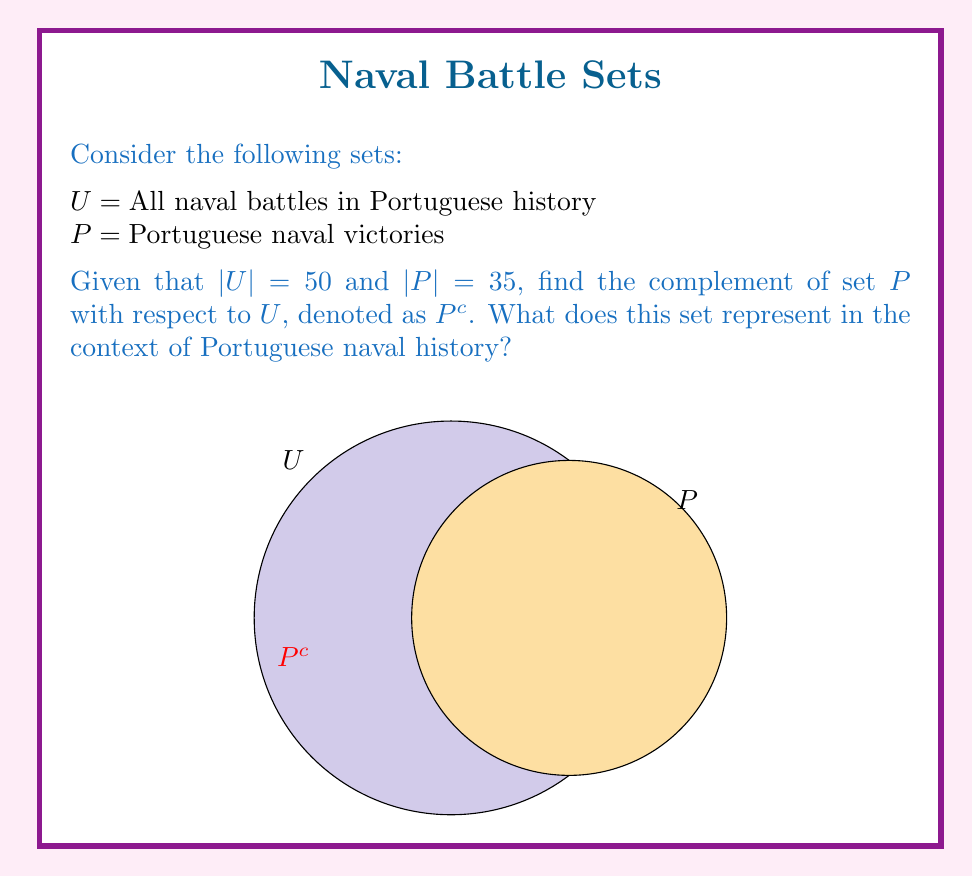Can you solve this math problem? To solve this problem, we'll follow these steps:

1) First, let's recall the definition of a complement:
   The complement of set $P$ with respect to $U$, denoted $P^c$, is the set of all elements in $U$ that are not in $P$.

2) We can find the number of elements in $P^c$ using the following formula:
   $|P^c| = |U| - |P|$

3) We're given:
   $|U| = 50$ (total number of naval battles)
   $|P| = 35$ (number of Portuguese naval victories)

4) Let's substitute these values into our formula:
   $|P^c| = 50 - 35 = 15$

5) Interpretation:
   $P^c$ represents the set of naval battles in Portuguese history that were not victories for Portugal. These could be defeats or inconclusive engagements.

6) In set theory notation, we can write:
   $P^c = \{x \in U : x \notin P\}$

This result aligns with the historical context of Portugal's naval power. As a significant maritime nation during the Age of Discovery, Portugal won many naval battles but also faced some defeats and inconclusive engagements.
Answer: $P^c = 15$ naval battles (defeats or inconclusive engagements) 